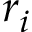<formula> <loc_0><loc_0><loc_500><loc_500>r _ { i }</formula> 